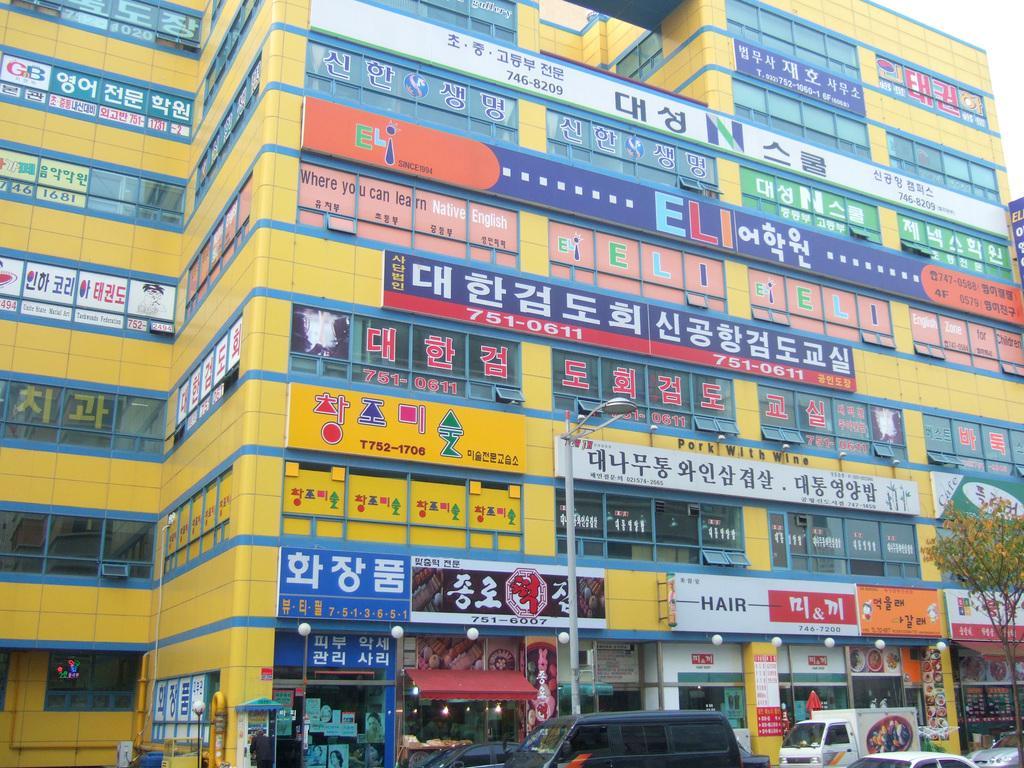Please provide a concise description of this image. In this picture we can see a building, few hoardings, lights, a tree and a pole, in front of the building, in front of the building we can find few vehicles. 